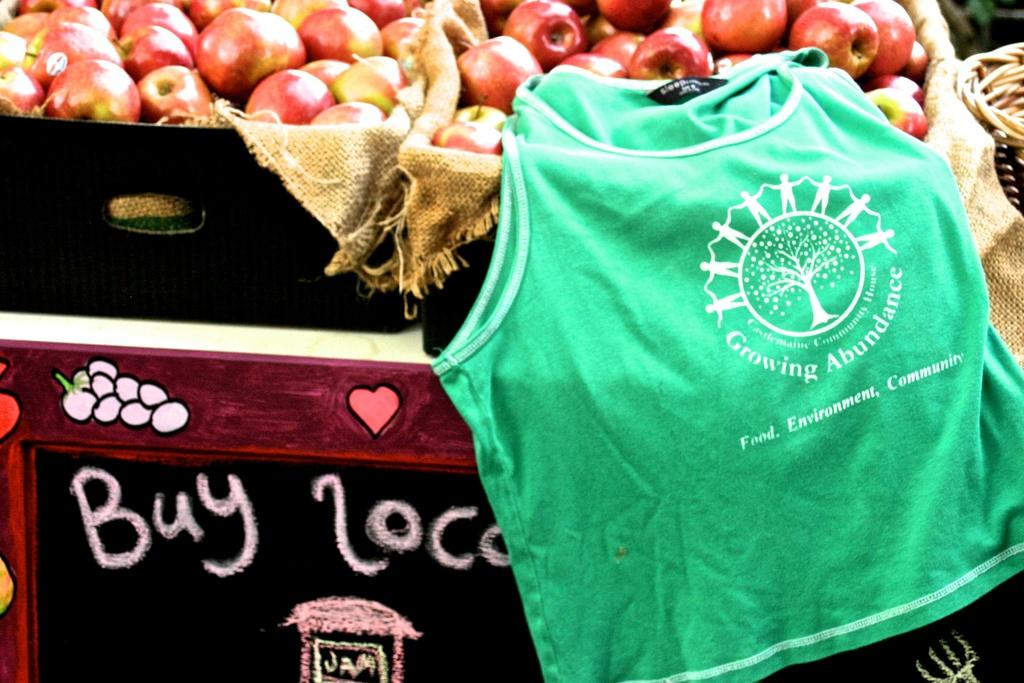What type of establishment is depicted in the image? There is a fruit stall in the image. What type of fruit can be seen on the stall? There is a basket of apples on the stall. What additional item is present on the stall? There is a green t-shirt on the stall. Can you see a stream flowing near the fruit stall in the image? There is no stream visible in the image; it only features a fruit stall with apples and a green t-shirt. 